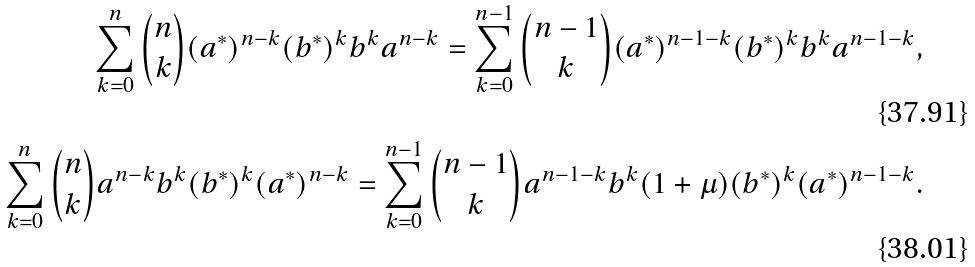<formula> <loc_0><loc_0><loc_500><loc_500>\sum _ { k = 0 } ^ { n } { n \choose k } ( a ^ { \ast } ) ^ { n - k } ( b ^ { \ast } ) ^ { k } b ^ { k } a ^ { n - k } = \sum _ { k = 0 } ^ { n - 1 } { n - 1 \choose k } ( a ^ { \ast } ) ^ { n - 1 - k } ( b ^ { \ast } ) ^ { k } b ^ { k } a ^ { n - 1 - k } , \\ \sum _ { k = 0 } ^ { n } { n \choose k } a ^ { n - k } b ^ { k } ( b ^ { \ast } ) ^ { k } ( a ^ { \ast } ) ^ { n - k } = \sum _ { k = 0 } ^ { n - 1 } { n - 1 \choose k } a ^ { n - 1 - k } b ^ { k } ( 1 + \mu ) ( b ^ { \ast } ) ^ { k } ( a ^ { \ast } ) ^ { n - 1 - k } .</formula> 